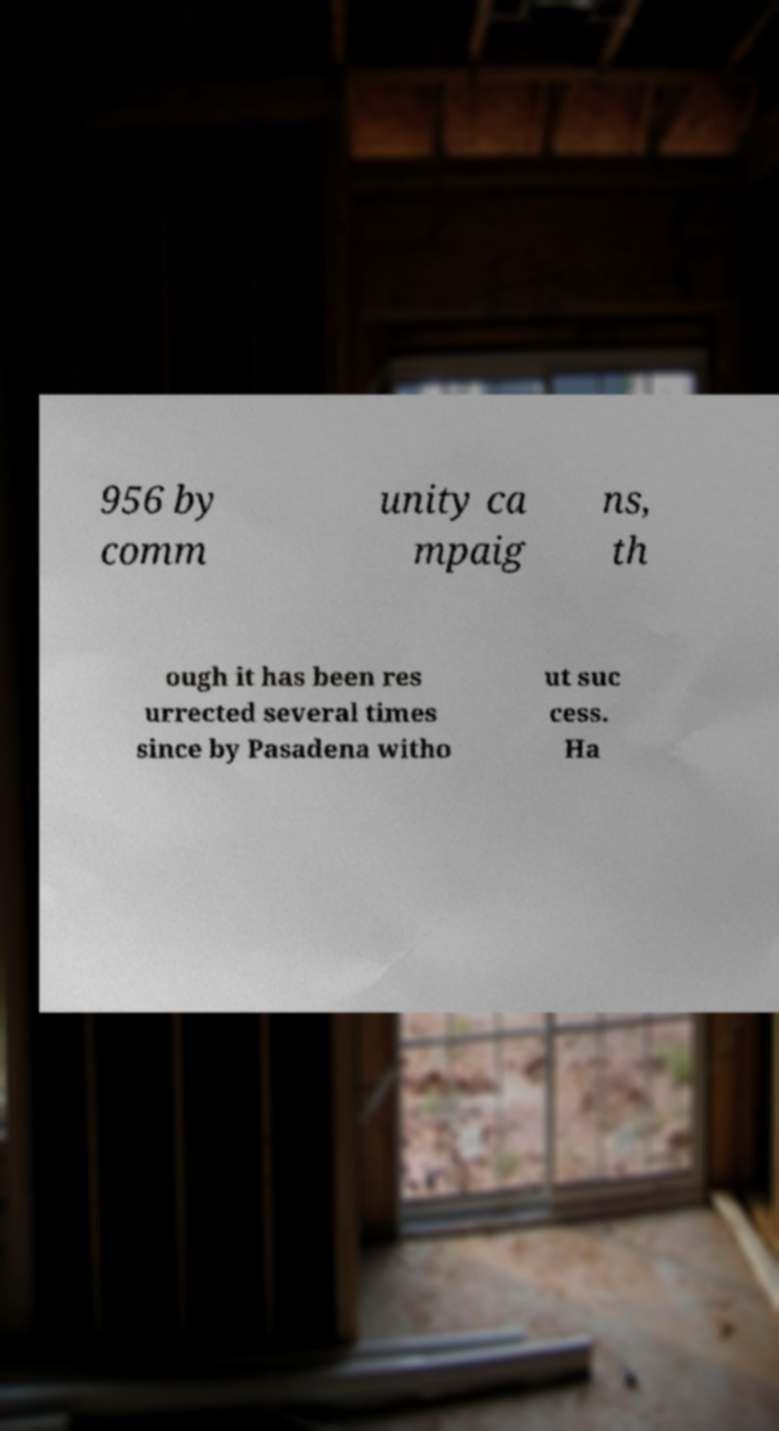For documentation purposes, I need the text within this image transcribed. Could you provide that? 956 by comm unity ca mpaig ns, th ough it has been res urrected several times since by Pasadena witho ut suc cess. Ha 